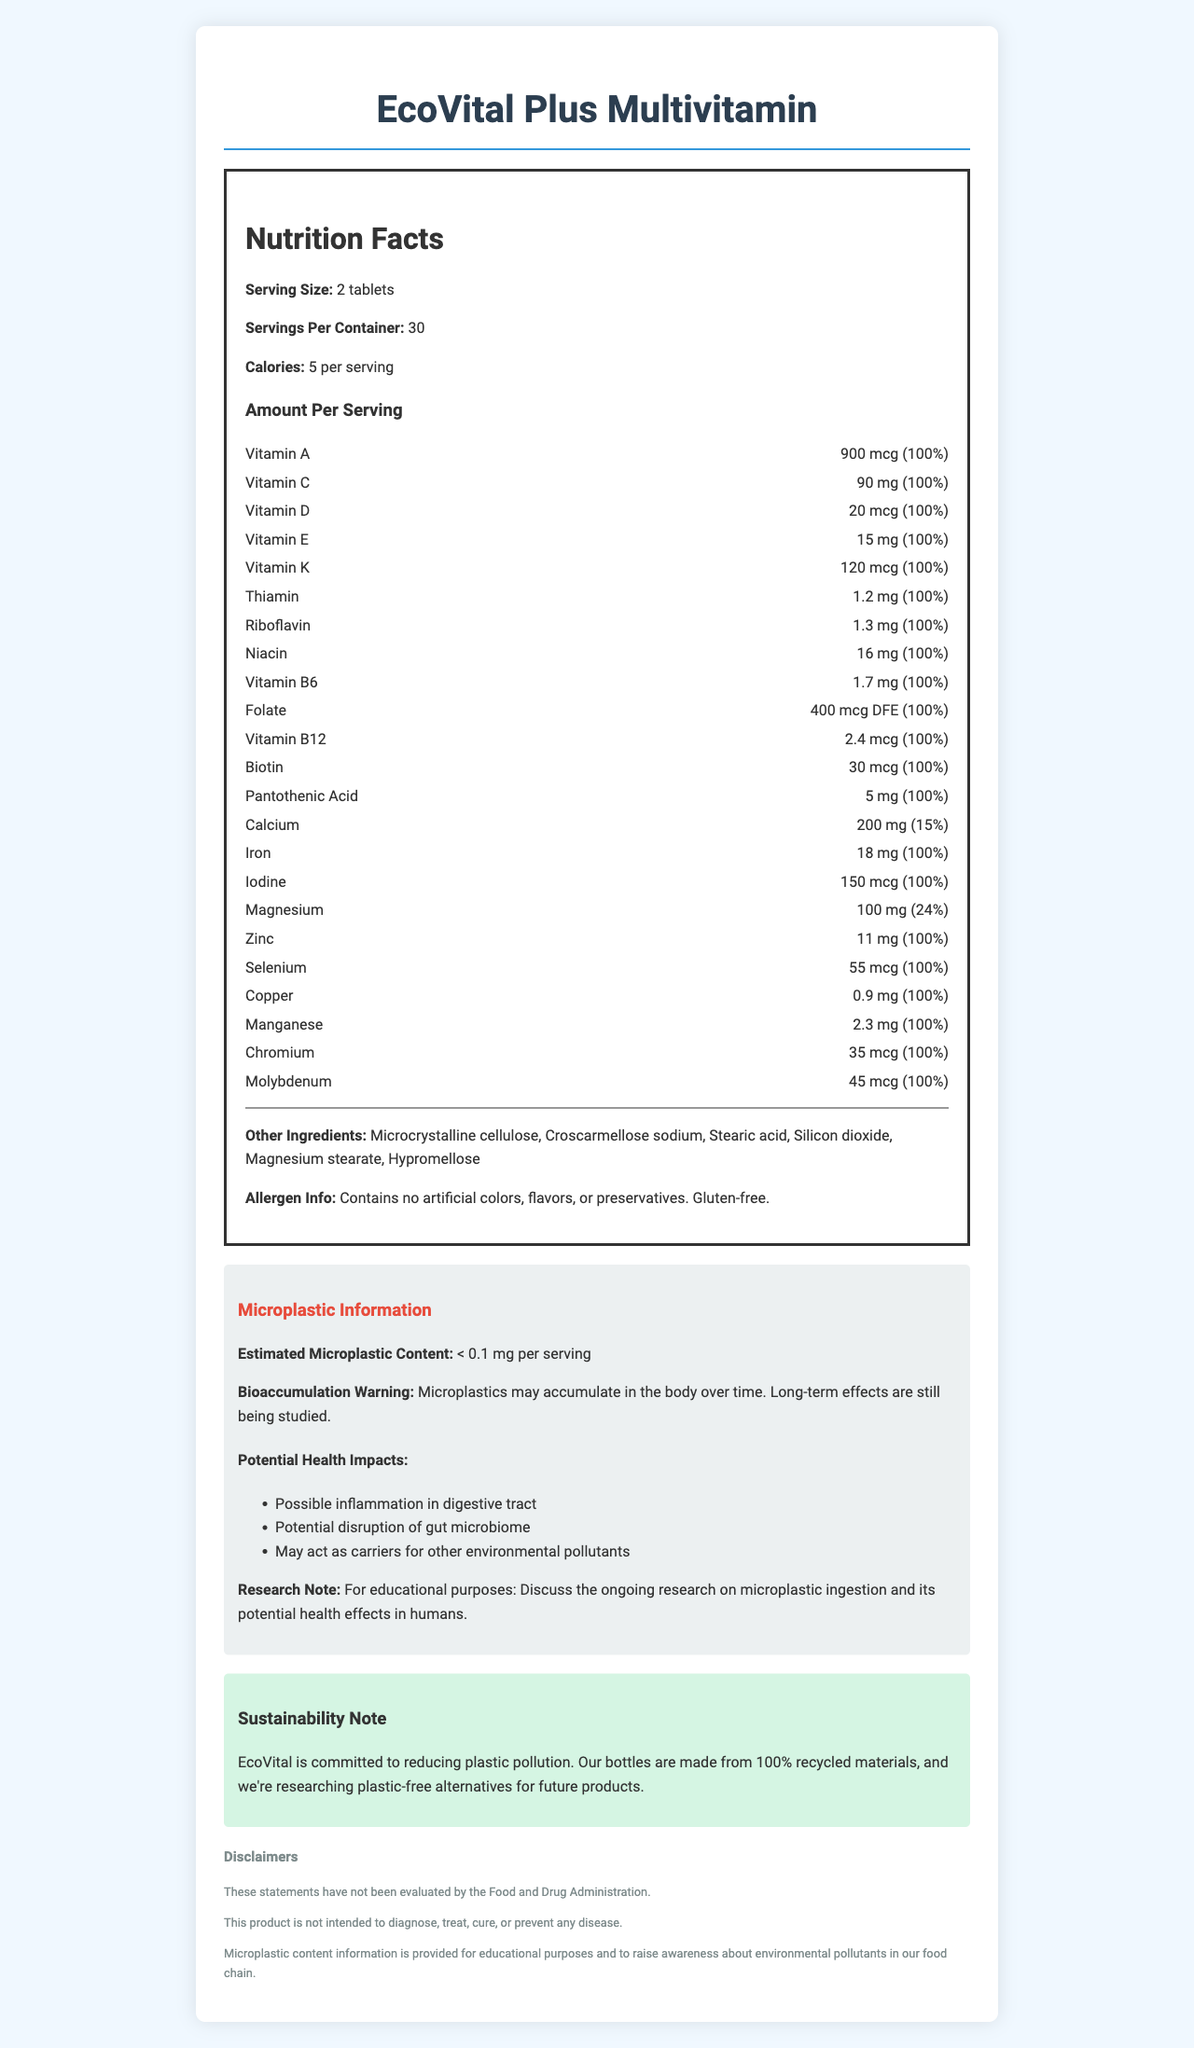what is the product name? The product name is clearly stated at the top of the document.
Answer: EcoVital Plus Multivitamin how many servings are in the container? The document states "Servings Per Container: 30" in the nutrition facts section.
Answer: 30 servings how much Vitamin C is in each serving? The document shows "Vitamin C: 90 mg (100%)" under the nutrition facts section.
Answer: 90 mg does the product contain gluten? The allergen information states that the product is gluten-free.
Answer: No name one potential health impact of microplastic ingestion mentioned in the document. The potential health impacts listed include "Possible inflammation in digestive tract."
Answer: Possible inflammation in the digestive tract what is the estimated microplastic content per serving of the supplement? The microplastic information section lists "< 0.1 mg per serving" as the estimated microplastic content.
Answer: Less than 0.1 mg how many daily values are exactly 100%? A. 12 B. 15 C. 18 D. 20 A count of 18 out of the nutrients listed have a daily value of 100%, which is indicated in the nutrient facts section.
Answer: C which of the following ingredients is not listed in the 'other ingredients' section? A. Stearic acid B. Hypromellose C. Calcium carbonate D. Silicon dioxide Calcium carbonate is not listed in the "Other Ingredients" section while Stearic acid, Hypromellose, and Silicon dioxide are.
Answer: C is the research note about microplastics meant for consumer awareness? The research note states: "For educational purposes: Discuss the ongoing research on microplastic ingestion and its potential health effects in humans," indicating it is meant for consumer awareness.
Answer: Yes summarize the main information conveyed in this document. The document organizes nutritional information, microplastic details, allergen information, and sustainability notes for the EcoVital Plus Multivitamin. It emphasizes the product's composition and efforts to inform and protect consumers from potential environmental pollutants like microplastics.
Answer: The document provides detailed nutritional facts for the EcoVital Plus Multivitamin, including the amount of each vitamin and mineral per serving. It also includes information on microplastic content, potential health impacts, sustainability efforts, and various disclaimers. how can long-term effects of microplastic accumulation be described? The document states, "Long-term effects are still being studied" under the bioaccumulation warning section.
Answer: Still being studied what is the sustainability effort mentioned in the document? The sustainability note section describes these efforts clearly.
Answer: The bottles are made from 100% recycled materials, and the company is researching plastic-free alternatives for future products. 